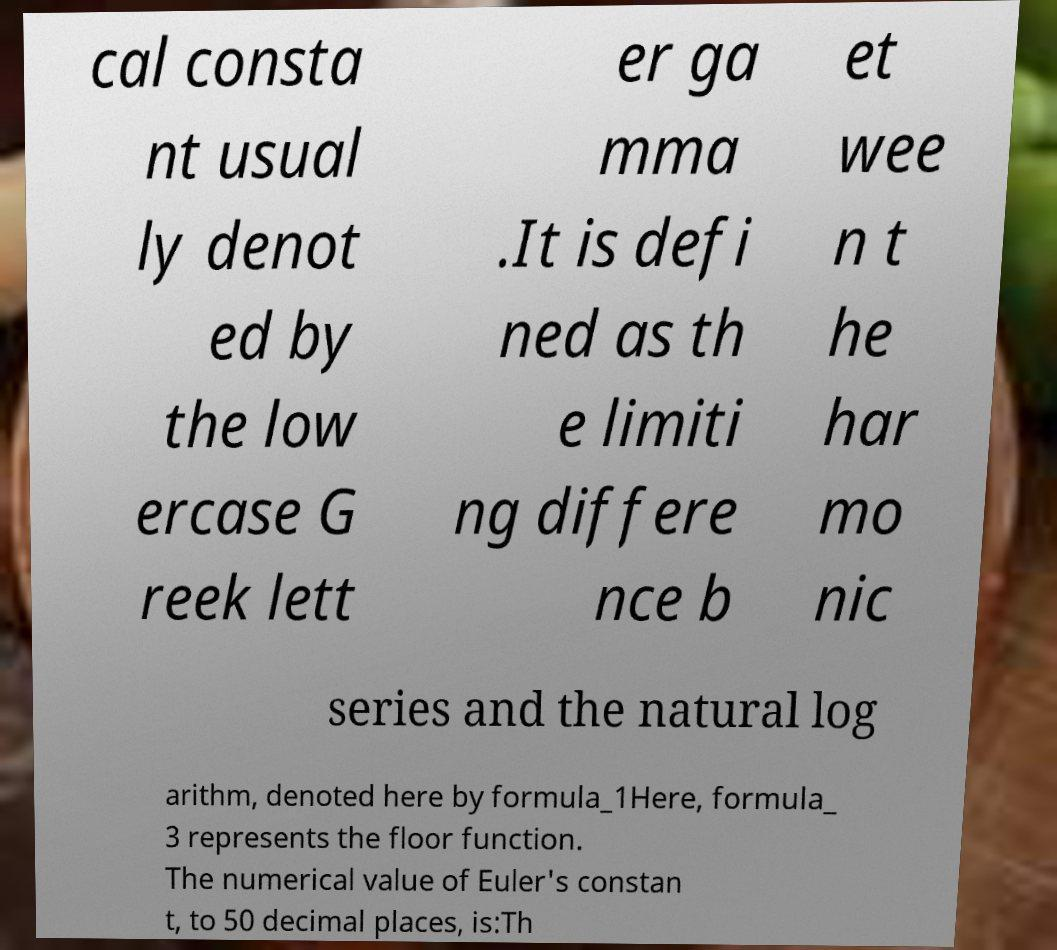Can you accurately transcribe the text from the provided image for me? cal consta nt usual ly denot ed by the low ercase G reek lett er ga mma .It is defi ned as th e limiti ng differe nce b et wee n t he har mo nic series and the natural log arithm, denoted here by formula_1Here, formula_ 3 represents the floor function. The numerical value of Euler's constan t, to 50 decimal places, is:Th 